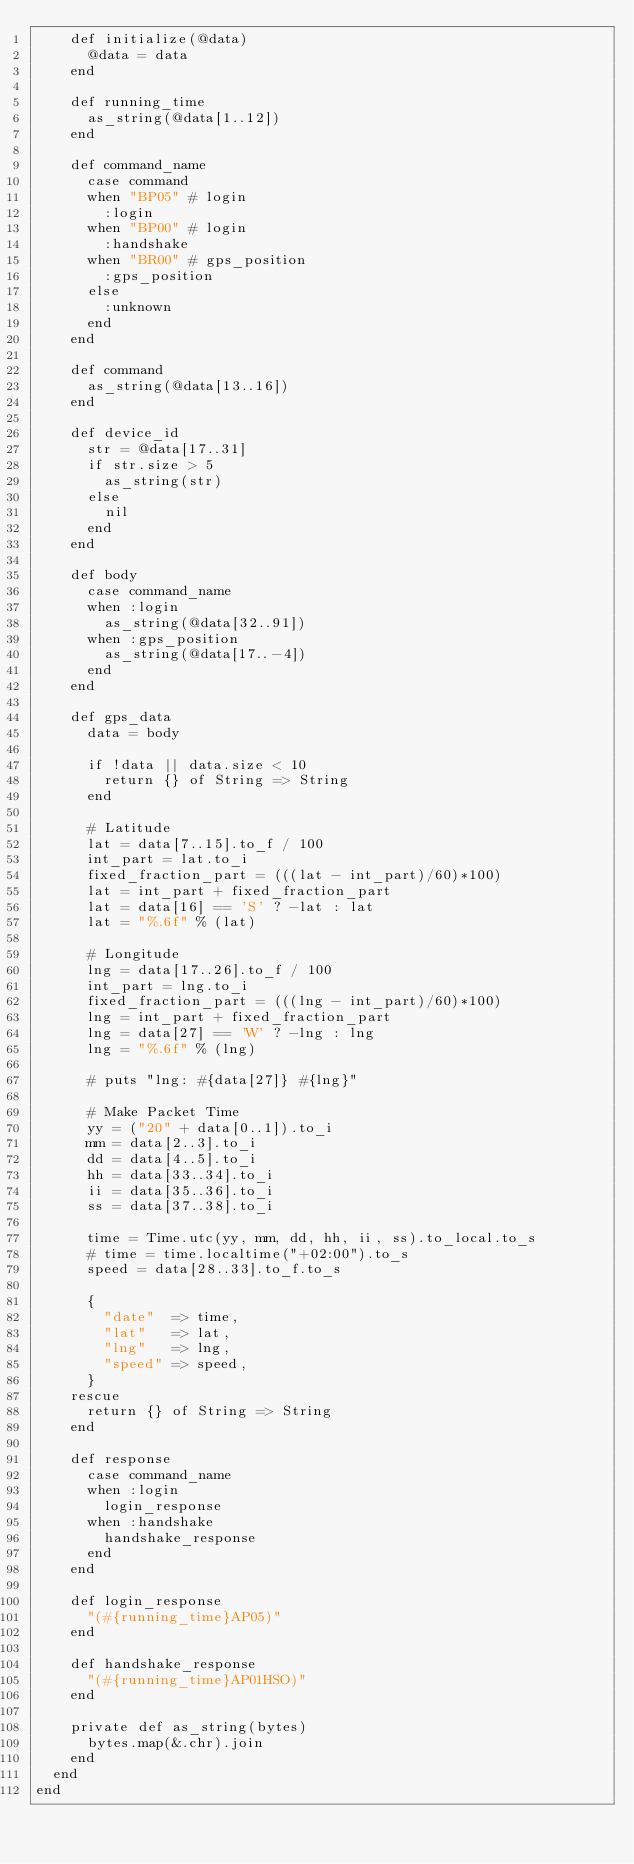Convert code to text. <code><loc_0><loc_0><loc_500><loc_500><_Crystal_>    def initialize(@data)
      @data = data
    end

    def running_time
      as_string(@data[1..12])
    end

    def command_name
      case command
      when "BP05" # login
        :login
      when "BP00" # login
        :handshake
      when "BR00" # gps_position
        :gps_position
      else
        :unknown
      end
    end

    def command
      as_string(@data[13..16])
    end

    def device_id
      str = @data[17..31]
      if str.size > 5
        as_string(str)
      else
        nil
      end
    end

    def body
      case command_name
      when :login
        as_string(@data[32..91])
      when :gps_position
        as_string(@data[17..-4])
      end
    end

    def gps_data
      data = body

      if !data || data.size < 10
        return {} of String => String
      end

      # Latitude
      lat = data[7..15].to_f / 100
      int_part = lat.to_i
      fixed_fraction_part = (((lat - int_part)/60)*100)
      lat = int_part + fixed_fraction_part
      lat = data[16] == 'S' ? -lat : lat
      lat = "%.6f" % (lat)

      # Longitude
      lng = data[17..26].to_f / 100
      int_part = lng.to_i
      fixed_fraction_part = (((lng - int_part)/60)*100)
      lng = int_part + fixed_fraction_part
      lng = data[27] == 'W' ? -lng : lng
      lng = "%.6f" % (lng)

      # puts "lng: #{data[27]} #{lng}"

      # Make Packet Time
      yy = ("20" + data[0..1]).to_i
      mm = data[2..3].to_i
      dd = data[4..5].to_i
      hh = data[33..34].to_i
      ii = data[35..36].to_i
      ss = data[37..38].to_i

      time = Time.utc(yy, mm, dd, hh, ii, ss).to_local.to_s
      # time = time.localtime("+02:00").to_s
      speed = data[28..33].to_f.to_s

      {
        "date"  => time,
        "lat"   => lat,
        "lng"   => lng,
        "speed" => speed,
      }
    rescue
      return {} of String => String
    end

    def response
      case command_name
      when :login
        login_response
      when :handshake
        handshake_response
      end
    end

    def login_response
      "(#{running_time}AP05)"
    end

    def handshake_response
      "(#{running_time}AP01HSO)"
    end

    private def as_string(bytes)
      bytes.map(&.chr).join
    end
  end
end
</code> 